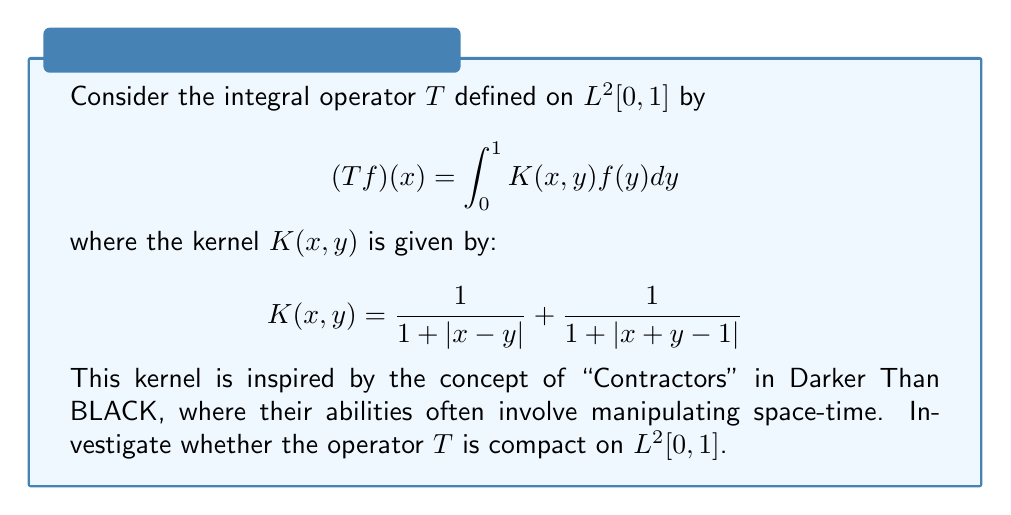Could you help me with this problem? To determine if the integral operator $T$ is compact, we'll use the Arzelà–Ascoli theorem. We need to show that $T$ maps bounded sets to relatively compact sets.

Step 1: Show that $T$ is bounded.
The kernel $K(x,y)$ is continuous on $[0,1] \times [0,1]$, so it's bounded. Let $M = \sup_{x,y \in [0,1]} |K(x,y)|$.

For $f \in L^2[0,1]$:
$$\|Tf\|_2^2 = \int_0^1 |(Tf)(x)|^2 dx \leq M^2 \int_0^1 \left(\int_0^1 |f(y)| dy\right)^2 dx$$

By Cauchy-Schwarz:
$$\|Tf\|_2^2 \leq M^2 \cdot 1 \cdot \|f\|_2^2$$

Thus, $T$ is bounded.

Step 2: Show that $T$ maps to a family of equicontinuous functions.
For $x_1, x_2 \in [0,1]$:

$$|(Tf)(x_1) - (Tf)(x_2)| \leq \int_0^1 |K(x_1,y) - K(x_2,y)| |f(y)| dy$$

The difference $|K(x_1,y) - K(x_2,y)|$ can be made arbitrarily small by choosing $|x_1 - x_2|$ small enough, uniformly in $y$. This shows equicontinuity.

Step 3: Show that $T$ maps to a pointwise bounded family.
For any $x \in [0,1]$:

$$|(Tf)(x)| \leq M \int_0^1 |f(y)| dy \leq M \|f\|_2$$

This shows pointwise boundedness.

By the Arzelà–Ascoli theorem, $T$ maps bounded sets in $L^2[0,1]$ to relatively compact sets. Therefore, $T$ is a compact operator on $L^2[0,1]$.
Answer: $T$ is compact on $L^2[0,1]$. 